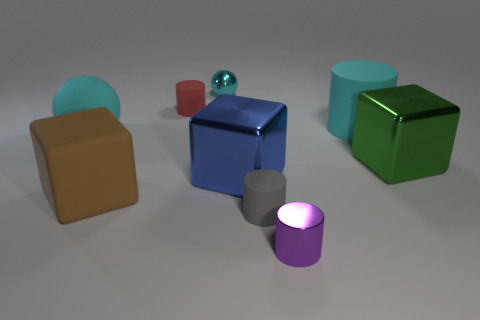Is there any other thing that is the same size as the purple object?
Offer a very short reply. Yes. There is a large thing left of the big brown rubber block; is it the same color as the matte block?
Offer a terse response. No. How many spheres are either large cyan things or red objects?
Ensure brevity in your answer.  1. What shape is the cyan matte thing to the left of the big brown matte cube?
Offer a very short reply. Sphere. There is a metal object that is in front of the matte cube left of the cyan matte thing that is to the right of the tiny purple thing; what is its color?
Give a very brief answer. Purple. Are the gray object and the large brown block made of the same material?
Ensure brevity in your answer.  Yes. What number of cyan things are either tiny cylinders or large balls?
Keep it short and to the point. 1. There is a tiny metallic cylinder; how many metal cubes are on the right side of it?
Give a very brief answer. 1. Are there more rubber objects than small yellow objects?
Offer a very short reply. Yes. What is the shape of the small thing that is to the left of the metal object that is behind the big rubber ball?
Provide a succinct answer. Cylinder. 